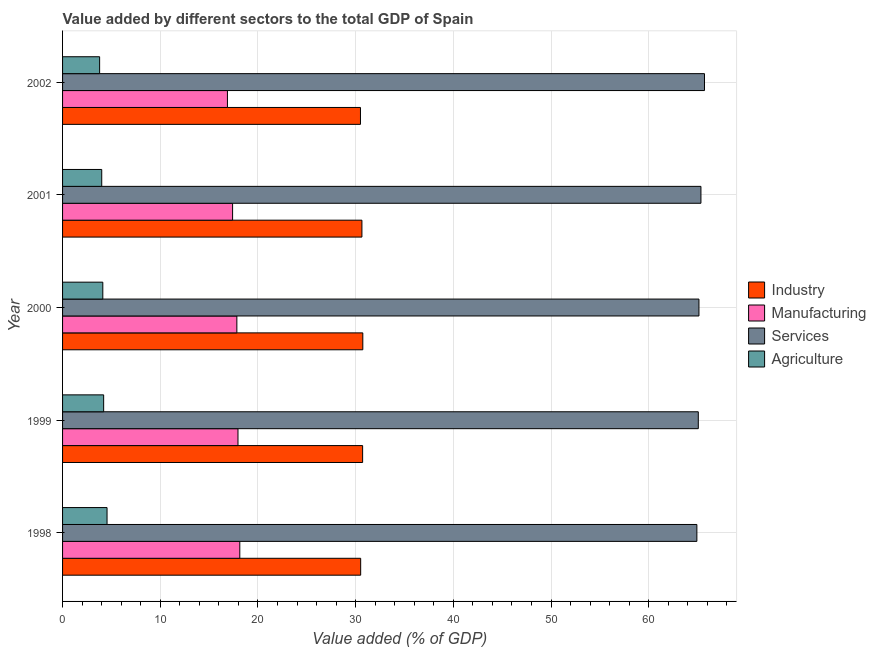How many different coloured bars are there?
Your answer should be very brief. 4. How many bars are there on the 2nd tick from the bottom?
Keep it short and to the point. 4. What is the value added by industrial sector in 1998?
Make the answer very short. 30.52. Across all years, what is the maximum value added by manufacturing sector?
Provide a short and direct response. 18.14. Across all years, what is the minimum value added by services sector?
Offer a very short reply. 64.93. In which year was the value added by services sector maximum?
Provide a succinct answer. 2002. In which year was the value added by services sector minimum?
Ensure brevity in your answer.  1998. What is the total value added by industrial sector in the graph?
Keep it short and to the point. 153.1. What is the difference between the value added by agricultural sector in 2000 and that in 2001?
Your answer should be compact. 0.11. What is the difference between the value added by services sector in 2000 and the value added by manufacturing sector in 1998?
Your answer should be very brief. 47. What is the average value added by agricultural sector per year?
Offer a very short reply. 4.14. In the year 1999, what is the difference between the value added by services sector and value added by agricultural sector?
Your answer should be compact. 60.87. What is the ratio of the value added by agricultural sector in 2000 to that in 2001?
Your response must be concise. 1.03. What is the difference between the highest and the second highest value added by industrial sector?
Your answer should be compact. 0.02. What is the difference between the highest and the lowest value added by manufacturing sector?
Your answer should be compact. 1.27. What does the 2nd bar from the top in 2000 represents?
Provide a short and direct response. Services. What does the 3rd bar from the bottom in 2002 represents?
Give a very brief answer. Services. Is it the case that in every year, the sum of the value added by industrial sector and value added by manufacturing sector is greater than the value added by services sector?
Your answer should be very brief. No. How many bars are there?
Keep it short and to the point. 20. Are the values on the major ticks of X-axis written in scientific E-notation?
Ensure brevity in your answer.  No. How many legend labels are there?
Your response must be concise. 4. How are the legend labels stacked?
Your answer should be compact. Vertical. What is the title of the graph?
Offer a terse response. Value added by different sectors to the total GDP of Spain. What is the label or title of the X-axis?
Your answer should be very brief. Value added (% of GDP). What is the label or title of the Y-axis?
Offer a terse response. Year. What is the Value added (% of GDP) of Industry in 1998?
Offer a terse response. 30.52. What is the Value added (% of GDP) in Manufacturing in 1998?
Your answer should be compact. 18.14. What is the Value added (% of GDP) of Services in 1998?
Make the answer very short. 64.93. What is the Value added (% of GDP) of Agriculture in 1998?
Offer a very short reply. 4.55. What is the Value added (% of GDP) of Industry in 1999?
Provide a short and direct response. 30.72. What is the Value added (% of GDP) in Manufacturing in 1999?
Your response must be concise. 17.96. What is the Value added (% of GDP) of Services in 1999?
Provide a succinct answer. 65.08. What is the Value added (% of GDP) of Agriculture in 1999?
Keep it short and to the point. 4.21. What is the Value added (% of GDP) of Industry in 2000?
Keep it short and to the point. 30.74. What is the Value added (% of GDP) of Manufacturing in 2000?
Give a very brief answer. 17.84. What is the Value added (% of GDP) in Services in 2000?
Provide a succinct answer. 65.14. What is the Value added (% of GDP) of Agriculture in 2000?
Your answer should be compact. 4.12. What is the Value added (% of GDP) of Industry in 2001?
Provide a succinct answer. 30.64. What is the Value added (% of GDP) of Manufacturing in 2001?
Provide a short and direct response. 17.41. What is the Value added (% of GDP) of Services in 2001?
Keep it short and to the point. 65.35. What is the Value added (% of GDP) in Agriculture in 2001?
Offer a terse response. 4.01. What is the Value added (% of GDP) of Industry in 2002?
Offer a very short reply. 30.49. What is the Value added (% of GDP) of Manufacturing in 2002?
Your response must be concise. 16.88. What is the Value added (% of GDP) in Services in 2002?
Provide a short and direct response. 65.71. What is the Value added (% of GDP) in Agriculture in 2002?
Offer a terse response. 3.79. Across all years, what is the maximum Value added (% of GDP) in Industry?
Ensure brevity in your answer.  30.74. Across all years, what is the maximum Value added (% of GDP) in Manufacturing?
Keep it short and to the point. 18.14. Across all years, what is the maximum Value added (% of GDP) of Services?
Ensure brevity in your answer.  65.71. Across all years, what is the maximum Value added (% of GDP) in Agriculture?
Give a very brief answer. 4.55. Across all years, what is the minimum Value added (% of GDP) of Industry?
Offer a terse response. 30.49. Across all years, what is the minimum Value added (% of GDP) of Manufacturing?
Ensure brevity in your answer.  16.88. Across all years, what is the minimum Value added (% of GDP) of Services?
Offer a very short reply. 64.93. Across all years, what is the minimum Value added (% of GDP) in Agriculture?
Offer a very short reply. 3.79. What is the total Value added (% of GDP) of Industry in the graph?
Give a very brief answer. 153.1. What is the total Value added (% of GDP) in Manufacturing in the graph?
Your answer should be very brief. 88.22. What is the total Value added (% of GDP) in Services in the graph?
Offer a terse response. 326.21. What is the total Value added (% of GDP) of Agriculture in the graph?
Your answer should be very brief. 20.68. What is the difference between the Value added (% of GDP) in Industry in 1998 and that in 1999?
Offer a very short reply. -0.2. What is the difference between the Value added (% of GDP) in Manufacturing in 1998 and that in 1999?
Provide a short and direct response. 0.18. What is the difference between the Value added (% of GDP) of Services in 1998 and that in 1999?
Provide a succinct answer. -0.15. What is the difference between the Value added (% of GDP) of Agriculture in 1998 and that in 1999?
Offer a very short reply. 0.35. What is the difference between the Value added (% of GDP) in Industry in 1998 and that in 2000?
Provide a succinct answer. -0.22. What is the difference between the Value added (% of GDP) of Manufacturing in 1998 and that in 2000?
Give a very brief answer. 0.3. What is the difference between the Value added (% of GDP) of Services in 1998 and that in 2000?
Keep it short and to the point. -0.21. What is the difference between the Value added (% of GDP) of Agriculture in 1998 and that in 2000?
Your answer should be compact. 0.43. What is the difference between the Value added (% of GDP) of Industry in 1998 and that in 2001?
Offer a very short reply. -0.13. What is the difference between the Value added (% of GDP) of Manufacturing in 1998 and that in 2001?
Give a very brief answer. 0.74. What is the difference between the Value added (% of GDP) of Services in 1998 and that in 2001?
Your answer should be very brief. -0.42. What is the difference between the Value added (% of GDP) in Agriculture in 1998 and that in 2001?
Give a very brief answer. 0.54. What is the difference between the Value added (% of GDP) in Industry in 1998 and that in 2002?
Give a very brief answer. 0.02. What is the difference between the Value added (% of GDP) in Manufacturing in 1998 and that in 2002?
Your response must be concise. 1.27. What is the difference between the Value added (% of GDP) in Services in 1998 and that in 2002?
Offer a very short reply. -0.78. What is the difference between the Value added (% of GDP) in Agriculture in 1998 and that in 2002?
Keep it short and to the point. 0.76. What is the difference between the Value added (% of GDP) of Industry in 1999 and that in 2000?
Provide a succinct answer. -0.02. What is the difference between the Value added (% of GDP) in Manufacturing in 1999 and that in 2000?
Make the answer very short. 0.12. What is the difference between the Value added (% of GDP) of Services in 1999 and that in 2000?
Keep it short and to the point. -0.07. What is the difference between the Value added (% of GDP) of Agriculture in 1999 and that in 2000?
Keep it short and to the point. 0.09. What is the difference between the Value added (% of GDP) of Industry in 1999 and that in 2001?
Provide a succinct answer. 0.07. What is the difference between the Value added (% of GDP) of Manufacturing in 1999 and that in 2001?
Your answer should be very brief. 0.55. What is the difference between the Value added (% of GDP) in Services in 1999 and that in 2001?
Make the answer very short. -0.27. What is the difference between the Value added (% of GDP) of Agriculture in 1999 and that in 2001?
Your response must be concise. 0.2. What is the difference between the Value added (% of GDP) in Industry in 1999 and that in 2002?
Ensure brevity in your answer.  0.22. What is the difference between the Value added (% of GDP) of Manufacturing in 1999 and that in 2002?
Offer a terse response. 1.08. What is the difference between the Value added (% of GDP) of Services in 1999 and that in 2002?
Provide a succinct answer. -0.63. What is the difference between the Value added (% of GDP) in Agriculture in 1999 and that in 2002?
Provide a short and direct response. 0.41. What is the difference between the Value added (% of GDP) in Industry in 2000 and that in 2001?
Provide a succinct answer. 0.09. What is the difference between the Value added (% of GDP) of Manufacturing in 2000 and that in 2001?
Provide a short and direct response. 0.44. What is the difference between the Value added (% of GDP) of Services in 2000 and that in 2001?
Your answer should be compact. -0.2. What is the difference between the Value added (% of GDP) of Agriculture in 2000 and that in 2001?
Offer a terse response. 0.11. What is the difference between the Value added (% of GDP) of Industry in 2000 and that in 2002?
Provide a succinct answer. 0.24. What is the difference between the Value added (% of GDP) in Manufacturing in 2000 and that in 2002?
Offer a very short reply. 0.96. What is the difference between the Value added (% of GDP) in Services in 2000 and that in 2002?
Your answer should be compact. -0.57. What is the difference between the Value added (% of GDP) of Agriculture in 2000 and that in 2002?
Offer a terse response. 0.33. What is the difference between the Value added (% of GDP) of Industry in 2001 and that in 2002?
Your answer should be compact. 0.15. What is the difference between the Value added (% of GDP) of Manufacturing in 2001 and that in 2002?
Offer a terse response. 0.53. What is the difference between the Value added (% of GDP) in Services in 2001 and that in 2002?
Give a very brief answer. -0.36. What is the difference between the Value added (% of GDP) in Agriculture in 2001 and that in 2002?
Offer a very short reply. 0.22. What is the difference between the Value added (% of GDP) of Industry in 1998 and the Value added (% of GDP) of Manufacturing in 1999?
Your response must be concise. 12.56. What is the difference between the Value added (% of GDP) in Industry in 1998 and the Value added (% of GDP) in Services in 1999?
Offer a very short reply. -34.56. What is the difference between the Value added (% of GDP) of Industry in 1998 and the Value added (% of GDP) of Agriculture in 1999?
Your answer should be compact. 26.31. What is the difference between the Value added (% of GDP) of Manufacturing in 1998 and the Value added (% of GDP) of Services in 1999?
Offer a very short reply. -46.94. What is the difference between the Value added (% of GDP) of Manufacturing in 1998 and the Value added (% of GDP) of Agriculture in 1999?
Offer a terse response. 13.94. What is the difference between the Value added (% of GDP) in Services in 1998 and the Value added (% of GDP) in Agriculture in 1999?
Your response must be concise. 60.72. What is the difference between the Value added (% of GDP) of Industry in 1998 and the Value added (% of GDP) of Manufacturing in 2000?
Provide a succinct answer. 12.67. What is the difference between the Value added (% of GDP) in Industry in 1998 and the Value added (% of GDP) in Services in 2000?
Offer a terse response. -34.63. What is the difference between the Value added (% of GDP) in Industry in 1998 and the Value added (% of GDP) in Agriculture in 2000?
Provide a short and direct response. 26.39. What is the difference between the Value added (% of GDP) in Manufacturing in 1998 and the Value added (% of GDP) in Services in 2000?
Give a very brief answer. -47. What is the difference between the Value added (% of GDP) in Manufacturing in 1998 and the Value added (% of GDP) in Agriculture in 2000?
Ensure brevity in your answer.  14.02. What is the difference between the Value added (% of GDP) of Services in 1998 and the Value added (% of GDP) of Agriculture in 2000?
Ensure brevity in your answer.  60.81. What is the difference between the Value added (% of GDP) of Industry in 1998 and the Value added (% of GDP) of Manufacturing in 2001?
Provide a succinct answer. 13.11. What is the difference between the Value added (% of GDP) of Industry in 1998 and the Value added (% of GDP) of Services in 2001?
Provide a short and direct response. -34.83. What is the difference between the Value added (% of GDP) in Industry in 1998 and the Value added (% of GDP) in Agriculture in 2001?
Your response must be concise. 26.51. What is the difference between the Value added (% of GDP) in Manufacturing in 1998 and the Value added (% of GDP) in Services in 2001?
Your answer should be compact. -47.2. What is the difference between the Value added (% of GDP) of Manufacturing in 1998 and the Value added (% of GDP) of Agriculture in 2001?
Your response must be concise. 14.13. What is the difference between the Value added (% of GDP) in Services in 1998 and the Value added (% of GDP) in Agriculture in 2001?
Keep it short and to the point. 60.92. What is the difference between the Value added (% of GDP) in Industry in 1998 and the Value added (% of GDP) in Manufacturing in 2002?
Provide a short and direct response. 13.64. What is the difference between the Value added (% of GDP) of Industry in 1998 and the Value added (% of GDP) of Services in 2002?
Give a very brief answer. -35.2. What is the difference between the Value added (% of GDP) in Industry in 1998 and the Value added (% of GDP) in Agriculture in 2002?
Your response must be concise. 26.72. What is the difference between the Value added (% of GDP) of Manufacturing in 1998 and the Value added (% of GDP) of Services in 2002?
Give a very brief answer. -47.57. What is the difference between the Value added (% of GDP) of Manufacturing in 1998 and the Value added (% of GDP) of Agriculture in 2002?
Provide a short and direct response. 14.35. What is the difference between the Value added (% of GDP) of Services in 1998 and the Value added (% of GDP) of Agriculture in 2002?
Your answer should be very brief. 61.14. What is the difference between the Value added (% of GDP) of Industry in 1999 and the Value added (% of GDP) of Manufacturing in 2000?
Give a very brief answer. 12.87. What is the difference between the Value added (% of GDP) in Industry in 1999 and the Value added (% of GDP) in Services in 2000?
Provide a succinct answer. -34.43. What is the difference between the Value added (% of GDP) of Industry in 1999 and the Value added (% of GDP) of Agriculture in 2000?
Make the answer very short. 26.6. What is the difference between the Value added (% of GDP) in Manufacturing in 1999 and the Value added (% of GDP) in Services in 2000?
Keep it short and to the point. -47.19. What is the difference between the Value added (% of GDP) in Manufacturing in 1999 and the Value added (% of GDP) in Agriculture in 2000?
Offer a terse response. 13.84. What is the difference between the Value added (% of GDP) in Services in 1999 and the Value added (% of GDP) in Agriculture in 2000?
Your answer should be very brief. 60.96. What is the difference between the Value added (% of GDP) in Industry in 1999 and the Value added (% of GDP) in Manufacturing in 2001?
Your answer should be compact. 13.31. What is the difference between the Value added (% of GDP) of Industry in 1999 and the Value added (% of GDP) of Services in 2001?
Your response must be concise. -34.63. What is the difference between the Value added (% of GDP) in Industry in 1999 and the Value added (% of GDP) in Agriculture in 2001?
Your answer should be very brief. 26.71. What is the difference between the Value added (% of GDP) of Manufacturing in 1999 and the Value added (% of GDP) of Services in 2001?
Make the answer very short. -47.39. What is the difference between the Value added (% of GDP) in Manufacturing in 1999 and the Value added (% of GDP) in Agriculture in 2001?
Provide a short and direct response. 13.95. What is the difference between the Value added (% of GDP) of Services in 1999 and the Value added (% of GDP) of Agriculture in 2001?
Your response must be concise. 61.07. What is the difference between the Value added (% of GDP) in Industry in 1999 and the Value added (% of GDP) in Manufacturing in 2002?
Your response must be concise. 13.84. What is the difference between the Value added (% of GDP) of Industry in 1999 and the Value added (% of GDP) of Services in 2002?
Keep it short and to the point. -34.99. What is the difference between the Value added (% of GDP) in Industry in 1999 and the Value added (% of GDP) in Agriculture in 2002?
Offer a terse response. 26.92. What is the difference between the Value added (% of GDP) of Manufacturing in 1999 and the Value added (% of GDP) of Services in 2002?
Keep it short and to the point. -47.75. What is the difference between the Value added (% of GDP) of Manufacturing in 1999 and the Value added (% of GDP) of Agriculture in 2002?
Provide a short and direct response. 14.16. What is the difference between the Value added (% of GDP) of Services in 1999 and the Value added (% of GDP) of Agriculture in 2002?
Provide a succinct answer. 61.28. What is the difference between the Value added (% of GDP) of Industry in 2000 and the Value added (% of GDP) of Manufacturing in 2001?
Keep it short and to the point. 13.33. What is the difference between the Value added (% of GDP) of Industry in 2000 and the Value added (% of GDP) of Services in 2001?
Make the answer very short. -34.61. What is the difference between the Value added (% of GDP) of Industry in 2000 and the Value added (% of GDP) of Agriculture in 2001?
Make the answer very short. 26.73. What is the difference between the Value added (% of GDP) in Manufacturing in 2000 and the Value added (% of GDP) in Services in 2001?
Ensure brevity in your answer.  -47.51. What is the difference between the Value added (% of GDP) in Manufacturing in 2000 and the Value added (% of GDP) in Agriculture in 2001?
Your response must be concise. 13.83. What is the difference between the Value added (% of GDP) of Services in 2000 and the Value added (% of GDP) of Agriculture in 2001?
Your response must be concise. 61.13. What is the difference between the Value added (% of GDP) in Industry in 2000 and the Value added (% of GDP) in Manufacturing in 2002?
Offer a very short reply. 13.86. What is the difference between the Value added (% of GDP) in Industry in 2000 and the Value added (% of GDP) in Services in 2002?
Your answer should be compact. -34.98. What is the difference between the Value added (% of GDP) in Industry in 2000 and the Value added (% of GDP) in Agriculture in 2002?
Your answer should be very brief. 26.94. What is the difference between the Value added (% of GDP) in Manufacturing in 2000 and the Value added (% of GDP) in Services in 2002?
Your response must be concise. -47.87. What is the difference between the Value added (% of GDP) of Manufacturing in 2000 and the Value added (% of GDP) of Agriculture in 2002?
Give a very brief answer. 14.05. What is the difference between the Value added (% of GDP) in Services in 2000 and the Value added (% of GDP) in Agriculture in 2002?
Your answer should be very brief. 61.35. What is the difference between the Value added (% of GDP) of Industry in 2001 and the Value added (% of GDP) of Manufacturing in 2002?
Keep it short and to the point. 13.77. What is the difference between the Value added (% of GDP) in Industry in 2001 and the Value added (% of GDP) in Services in 2002?
Provide a succinct answer. -35.07. What is the difference between the Value added (% of GDP) in Industry in 2001 and the Value added (% of GDP) in Agriculture in 2002?
Offer a terse response. 26.85. What is the difference between the Value added (% of GDP) of Manufacturing in 2001 and the Value added (% of GDP) of Services in 2002?
Your response must be concise. -48.31. What is the difference between the Value added (% of GDP) of Manufacturing in 2001 and the Value added (% of GDP) of Agriculture in 2002?
Provide a succinct answer. 13.61. What is the difference between the Value added (% of GDP) of Services in 2001 and the Value added (% of GDP) of Agriculture in 2002?
Make the answer very short. 61.55. What is the average Value added (% of GDP) of Industry per year?
Provide a short and direct response. 30.62. What is the average Value added (% of GDP) in Manufacturing per year?
Keep it short and to the point. 17.64. What is the average Value added (% of GDP) of Services per year?
Ensure brevity in your answer.  65.24. What is the average Value added (% of GDP) in Agriculture per year?
Ensure brevity in your answer.  4.14. In the year 1998, what is the difference between the Value added (% of GDP) of Industry and Value added (% of GDP) of Manufacturing?
Provide a short and direct response. 12.37. In the year 1998, what is the difference between the Value added (% of GDP) in Industry and Value added (% of GDP) in Services?
Keep it short and to the point. -34.42. In the year 1998, what is the difference between the Value added (% of GDP) of Industry and Value added (% of GDP) of Agriculture?
Give a very brief answer. 25.96. In the year 1998, what is the difference between the Value added (% of GDP) of Manufacturing and Value added (% of GDP) of Services?
Offer a very short reply. -46.79. In the year 1998, what is the difference between the Value added (% of GDP) in Manufacturing and Value added (% of GDP) in Agriculture?
Give a very brief answer. 13.59. In the year 1998, what is the difference between the Value added (% of GDP) of Services and Value added (% of GDP) of Agriculture?
Provide a succinct answer. 60.38. In the year 1999, what is the difference between the Value added (% of GDP) of Industry and Value added (% of GDP) of Manufacturing?
Your answer should be compact. 12.76. In the year 1999, what is the difference between the Value added (% of GDP) of Industry and Value added (% of GDP) of Services?
Make the answer very short. -34.36. In the year 1999, what is the difference between the Value added (% of GDP) in Industry and Value added (% of GDP) in Agriculture?
Your answer should be compact. 26.51. In the year 1999, what is the difference between the Value added (% of GDP) in Manufacturing and Value added (% of GDP) in Services?
Your answer should be very brief. -47.12. In the year 1999, what is the difference between the Value added (% of GDP) in Manufacturing and Value added (% of GDP) in Agriculture?
Give a very brief answer. 13.75. In the year 1999, what is the difference between the Value added (% of GDP) of Services and Value added (% of GDP) of Agriculture?
Ensure brevity in your answer.  60.87. In the year 2000, what is the difference between the Value added (% of GDP) of Industry and Value added (% of GDP) of Manufacturing?
Provide a short and direct response. 12.89. In the year 2000, what is the difference between the Value added (% of GDP) in Industry and Value added (% of GDP) in Services?
Make the answer very short. -34.41. In the year 2000, what is the difference between the Value added (% of GDP) in Industry and Value added (% of GDP) in Agriculture?
Your response must be concise. 26.61. In the year 2000, what is the difference between the Value added (% of GDP) in Manufacturing and Value added (% of GDP) in Services?
Your answer should be compact. -47.3. In the year 2000, what is the difference between the Value added (% of GDP) in Manufacturing and Value added (% of GDP) in Agriculture?
Give a very brief answer. 13.72. In the year 2000, what is the difference between the Value added (% of GDP) of Services and Value added (% of GDP) of Agriculture?
Ensure brevity in your answer.  61.02. In the year 2001, what is the difference between the Value added (% of GDP) of Industry and Value added (% of GDP) of Manufacturing?
Offer a terse response. 13.24. In the year 2001, what is the difference between the Value added (% of GDP) in Industry and Value added (% of GDP) in Services?
Your answer should be compact. -34.7. In the year 2001, what is the difference between the Value added (% of GDP) of Industry and Value added (% of GDP) of Agriculture?
Make the answer very short. 26.63. In the year 2001, what is the difference between the Value added (% of GDP) in Manufacturing and Value added (% of GDP) in Services?
Give a very brief answer. -47.94. In the year 2001, what is the difference between the Value added (% of GDP) of Manufacturing and Value added (% of GDP) of Agriculture?
Give a very brief answer. 13.4. In the year 2001, what is the difference between the Value added (% of GDP) of Services and Value added (% of GDP) of Agriculture?
Your response must be concise. 61.34. In the year 2002, what is the difference between the Value added (% of GDP) of Industry and Value added (% of GDP) of Manufacturing?
Ensure brevity in your answer.  13.62. In the year 2002, what is the difference between the Value added (% of GDP) in Industry and Value added (% of GDP) in Services?
Keep it short and to the point. -35.22. In the year 2002, what is the difference between the Value added (% of GDP) in Industry and Value added (% of GDP) in Agriculture?
Your answer should be compact. 26.7. In the year 2002, what is the difference between the Value added (% of GDP) of Manufacturing and Value added (% of GDP) of Services?
Make the answer very short. -48.83. In the year 2002, what is the difference between the Value added (% of GDP) of Manufacturing and Value added (% of GDP) of Agriculture?
Offer a very short reply. 13.08. In the year 2002, what is the difference between the Value added (% of GDP) in Services and Value added (% of GDP) in Agriculture?
Provide a short and direct response. 61.92. What is the ratio of the Value added (% of GDP) in Manufacturing in 1998 to that in 1999?
Ensure brevity in your answer.  1.01. What is the ratio of the Value added (% of GDP) in Agriculture in 1998 to that in 1999?
Keep it short and to the point. 1.08. What is the ratio of the Value added (% of GDP) in Manufacturing in 1998 to that in 2000?
Ensure brevity in your answer.  1.02. What is the ratio of the Value added (% of GDP) in Services in 1998 to that in 2000?
Make the answer very short. 1. What is the ratio of the Value added (% of GDP) of Agriculture in 1998 to that in 2000?
Provide a short and direct response. 1.1. What is the ratio of the Value added (% of GDP) of Manufacturing in 1998 to that in 2001?
Your answer should be compact. 1.04. What is the ratio of the Value added (% of GDP) in Agriculture in 1998 to that in 2001?
Give a very brief answer. 1.14. What is the ratio of the Value added (% of GDP) of Manufacturing in 1998 to that in 2002?
Your answer should be very brief. 1.07. What is the ratio of the Value added (% of GDP) of Agriculture in 1998 to that in 2002?
Provide a succinct answer. 1.2. What is the ratio of the Value added (% of GDP) of Services in 1999 to that in 2000?
Your answer should be compact. 1. What is the ratio of the Value added (% of GDP) in Agriculture in 1999 to that in 2000?
Offer a terse response. 1.02. What is the ratio of the Value added (% of GDP) in Manufacturing in 1999 to that in 2001?
Provide a succinct answer. 1.03. What is the ratio of the Value added (% of GDP) of Agriculture in 1999 to that in 2001?
Your response must be concise. 1.05. What is the ratio of the Value added (% of GDP) in Industry in 1999 to that in 2002?
Provide a succinct answer. 1.01. What is the ratio of the Value added (% of GDP) in Manufacturing in 1999 to that in 2002?
Ensure brevity in your answer.  1.06. What is the ratio of the Value added (% of GDP) of Agriculture in 1999 to that in 2002?
Your answer should be very brief. 1.11. What is the ratio of the Value added (% of GDP) in Manufacturing in 2000 to that in 2001?
Ensure brevity in your answer.  1.02. What is the ratio of the Value added (% of GDP) of Agriculture in 2000 to that in 2001?
Your answer should be compact. 1.03. What is the ratio of the Value added (% of GDP) of Industry in 2000 to that in 2002?
Make the answer very short. 1.01. What is the ratio of the Value added (% of GDP) of Manufacturing in 2000 to that in 2002?
Offer a very short reply. 1.06. What is the ratio of the Value added (% of GDP) of Agriculture in 2000 to that in 2002?
Keep it short and to the point. 1.09. What is the ratio of the Value added (% of GDP) in Industry in 2001 to that in 2002?
Give a very brief answer. 1. What is the ratio of the Value added (% of GDP) of Manufacturing in 2001 to that in 2002?
Your answer should be very brief. 1.03. What is the ratio of the Value added (% of GDP) of Services in 2001 to that in 2002?
Offer a very short reply. 0.99. What is the ratio of the Value added (% of GDP) of Agriculture in 2001 to that in 2002?
Ensure brevity in your answer.  1.06. What is the difference between the highest and the second highest Value added (% of GDP) in Industry?
Give a very brief answer. 0.02. What is the difference between the highest and the second highest Value added (% of GDP) in Manufacturing?
Your answer should be compact. 0.18. What is the difference between the highest and the second highest Value added (% of GDP) in Services?
Offer a terse response. 0.36. What is the difference between the highest and the second highest Value added (% of GDP) of Agriculture?
Your answer should be very brief. 0.35. What is the difference between the highest and the lowest Value added (% of GDP) in Industry?
Provide a succinct answer. 0.24. What is the difference between the highest and the lowest Value added (% of GDP) of Manufacturing?
Your response must be concise. 1.27. What is the difference between the highest and the lowest Value added (% of GDP) in Services?
Make the answer very short. 0.78. What is the difference between the highest and the lowest Value added (% of GDP) in Agriculture?
Your answer should be very brief. 0.76. 